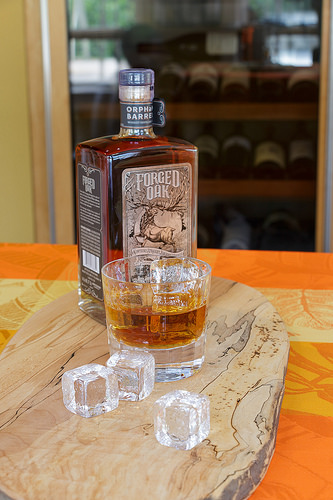<image>
Is there a glass on the table? Yes. Looking at the image, I can see the glass is positioned on top of the table, with the table providing support. Is there a ice to the left of the ice? No. The ice is not to the left of the ice. From this viewpoint, they have a different horizontal relationship. 